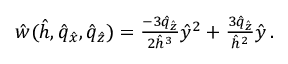<formula> <loc_0><loc_0><loc_500><loc_500>\begin{array} { r } { \hat { w } ( \hat { h } , \hat { q } _ { \hat { x } } , \hat { q } _ { \hat { z } } ) = \frac { - 3 \hat { q } _ { \hat { z } } } { 2 \hat { h } ^ { 3 } } \hat { y } ^ { 2 } + \frac { 3 \hat { q } _ { \hat { z } } } { \hat { h } ^ { 2 } } \hat { y } \, . } \end{array}</formula> 